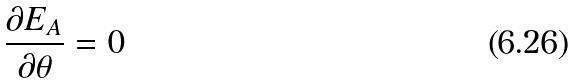Convert formula to latex. <formula><loc_0><loc_0><loc_500><loc_500>\frac { \partial E _ { A } } { \partial \theta } = 0</formula> 